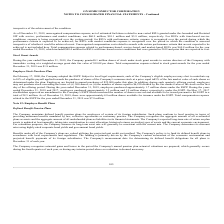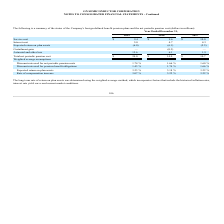According to On Semiconductor's financial document, What is the service cost in 2019? According to the financial document, $9.4 (in millions). The relevant text states: "Service cost $ 9.4 $ 9.6 $ 10.0..." Also, What is the service cost in 2018? According to the financial document, $9.6 (in millions). The relevant text states: "Service cost $ 9.4 $ 9.6 $ 10.0..." Also, What is the interest cost in 2018? According to the financial document, 4.7 (in millions). The relevant text states: "Interest cost 5.0 4.7 4.3..." Also, can you calculate: What is the change in Service cost from December 31, 2018 to 2019? Based on the calculation: 9.4-9.6, the result is -0.2 (in millions). This is based on the information: "Service cost $ 9.4 $ 9.6 $ 10.0 Service cost $ 9.4 $ 9.6 $ 10.0..." The key data points involved are: 9.4, 9.6. Also, can you calculate: What is the change in Interest cost from year ended December 31, 2018 to 2019? Based on the calculation: 5.0-4.7, the result is 0.3 (in millions). This is based on the information: "Interest cost 5.0 4.7 4.3 Interest cost 5.0 4.7 4.3..." The key data points involved are: 4.7, 5.0. Also, can you calculate: What is the average Service cost for December 31, 2018 and 2019? To answer this question, I need to perform calculations using the financial data. The calculation is: (9.4+9.6) / 2, which equals 9.5 (in millions). This is based on the information: "Service cost $ 9.4 $ 9.6 $ 10.0 Service cost $ 9.4 $ 9.6 $ 10.0..." The key data points involved are: 9.4, 9.6. 